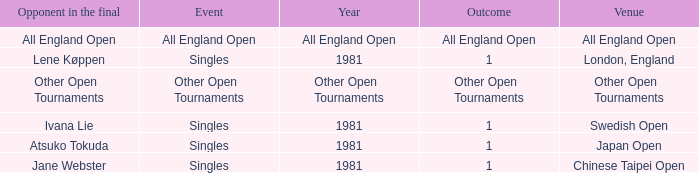What is the Outcome of the Singles Event in London, England? 1.0. 